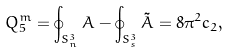<formula> <loc_0><loc_0><loc_500><loc_500>Q _ { 5 } ^ { m } = \oint _ { S _ { n } ^ { 3 } } A - \oint _ { S _ { s } ^ { 3 } } \tilde { A } = 8 \pi ^ { 2 } c _ { 2 } ,</formula> 